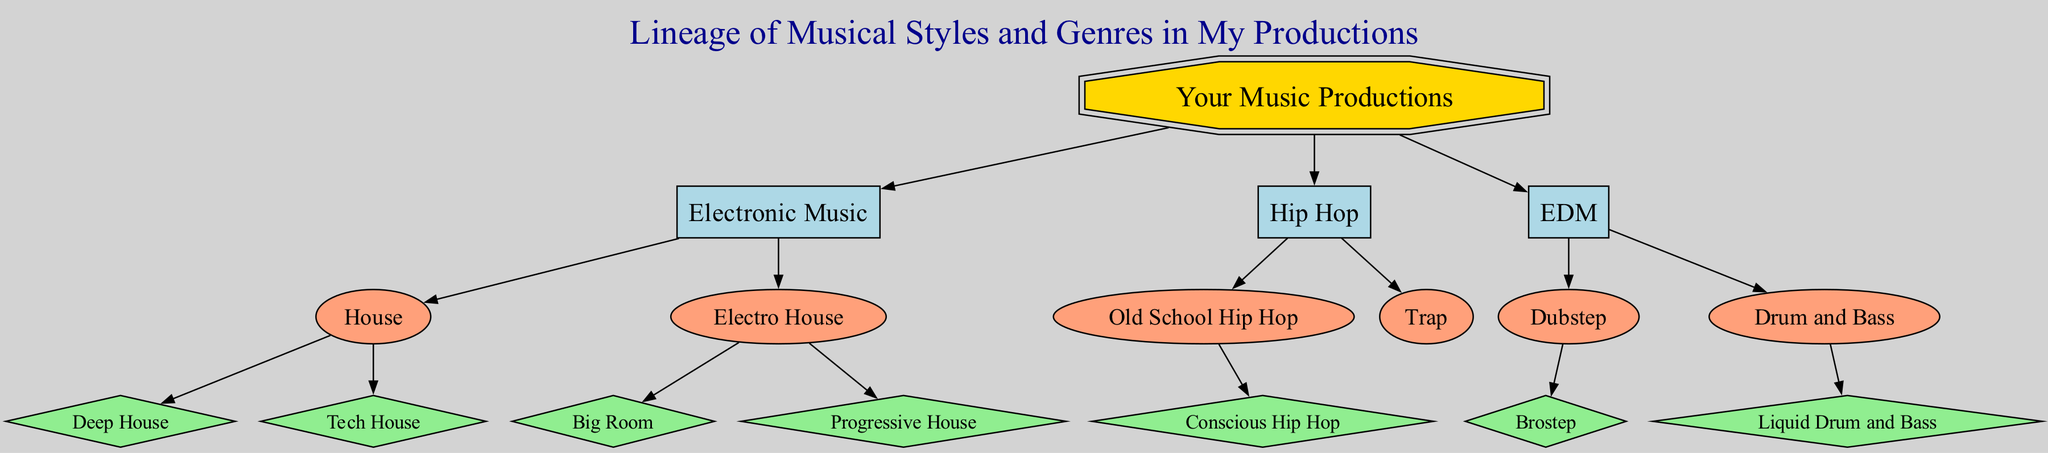What is the root of the family tree? The root node is identified as "Your Music Productions," which serves as the starting point for the lineage of musical styles and genres.
Answer: Your Music Productions How many genres are represented under your music productions? The diagram displays three main genres: Electronic Music, Hip Hop, and EDM. Counting these, there are a total of three genres.
Answer: 3 Which subgenre is derived from House? The subgenres derived from House are Deep House and Tech House. Since the question asks for one, I can mention either.
Answer: Deep House What type of node is "Big Room"? "Big Room" is classified as a variant in the diagram, as it is a specific type of music style stemming from the Electro House subgenre.
Answer: variant Which genre has "Liquid Drum and Bass" as a variant? "Liquid Drum and Bass" is a variant of the subgenre "Drum and Bass," which in turn is categorized under the EDM genre.
Answer: EDM How many total nodes are there in this diagram? By counting all nodes in the diagram, including root, genres, subgenres, and variants, we find there are a total of 15 nodes.
Answer: 15 What is the relationship between Trap and Hip Hop? Trap is a subgenre that branches off from the Hip Hop genre, indicating that it falls under the larger category of Hip Hop music.
Answer: subgenre Which subgenre has "Brostep" as a variant? "Brostep" is depicted as a variant under the Dubstep subgenre, which is a branch of the EDM genre.
Answer: Dubstep What are the two variants of Electro House? The two variants of Electro House indicated in the diagram are Big Room and Progressive House, reflecting different styles within that subgenre.
Answer: Big Room, Progressive House 